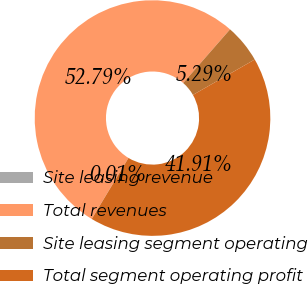Convert chart to OTSL. <chart><loc_0><loc_0><loc_500><loc_500><pie_chart><fcel>Site leasing revenue<fcel>Total revenues<fcel>Site leasing segment operating<fcel>Total segment operating profit<nl><fcel>0.01%<fcel>52.8%<fcel>5.29%<fcel>41.91%<nl></chart> 